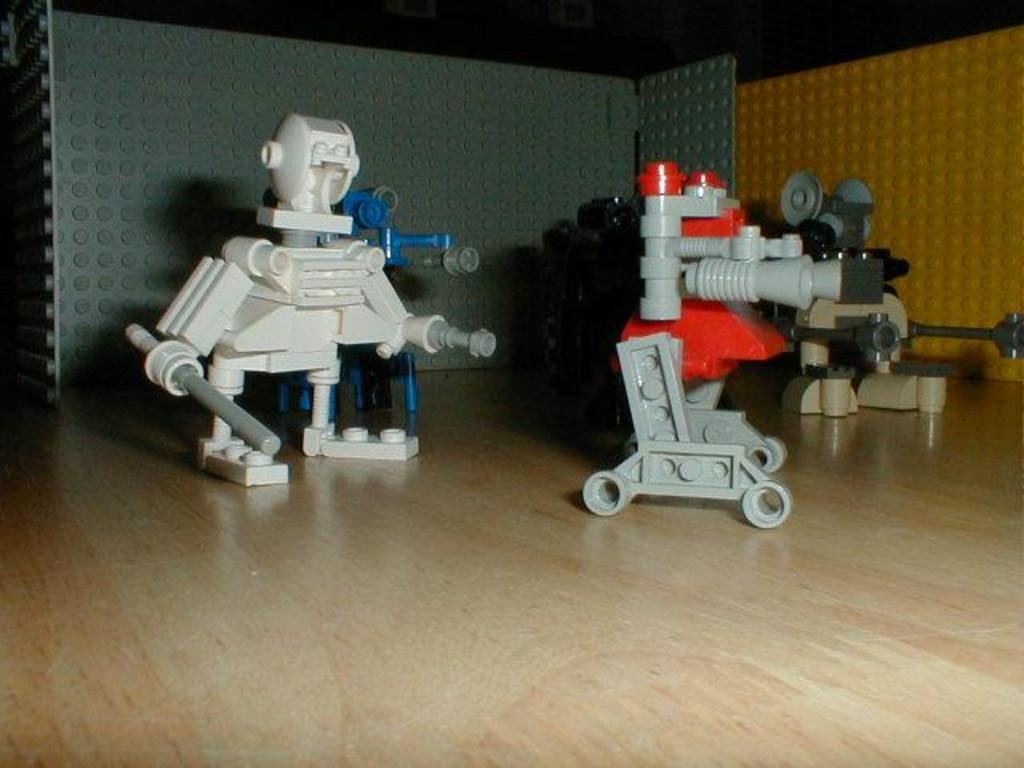What is the main subject of the image? The main subject of the image is toys on a cream color surface. What colors are the toys? The toys are in white, blue, and red colors. What colors can be seen in the background of the image? Grey and yellow color blocks are visible in the background of the image. What type of seed can be seen growing in the image? There is no seed or plant visible in the image; it features toys on a cream color surface with a background of grey and yellow color blocks. 